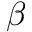<formula> <loc_0><loc_0><loc_500><loc_500>\beta</formula> 